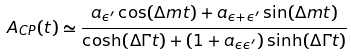<formula> <loc_0><loc_0><loc_500><loc_500>A _ { C P } ( t ) \simeq \frac { a _ { \epsilon ^ { \prime } } \cos ( \Delta m t ) + a _ { \epsilon + \epsilon ^ { \prime } } \sin ( \Delta m t ) } { \cosh ( \Delta \Gamma t ) + ( 1 + a _ { \epsilon \epsilon ^ { \prime } } ) \sinh ( \Delta \Gamma t ) }</formula> 